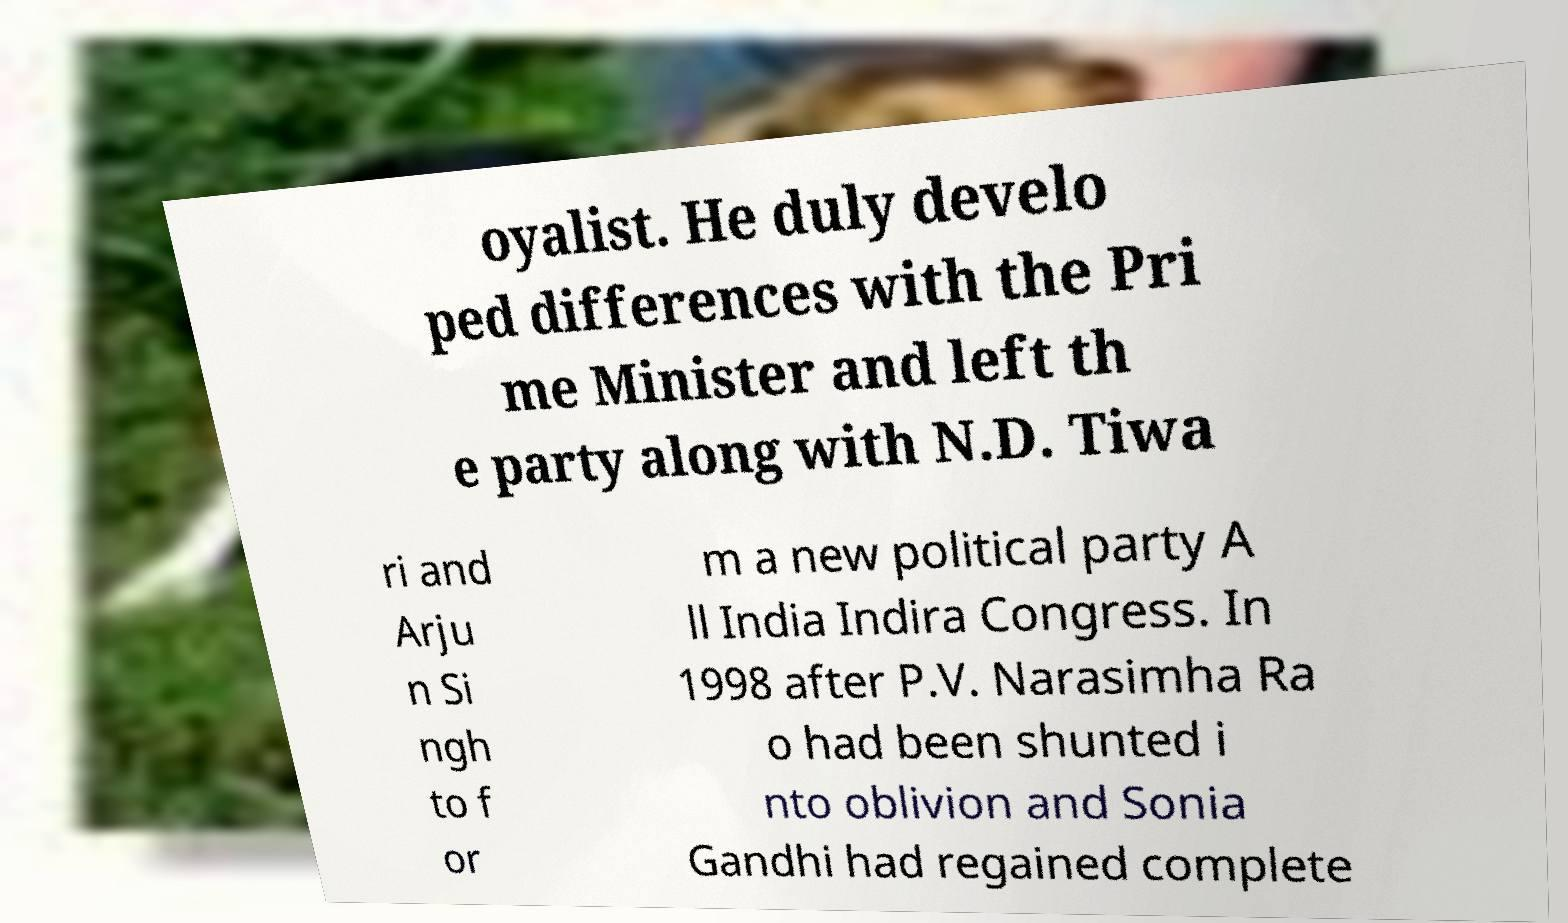Could you assist in decoding the text presented in this image and type it out clearly? oyalist. He duly develo ped differences with the Pri me Minister and left th e party along with N.D. Tiwa ri and Arju n Si ngh to f or m a new political party A ll India Indira Congress. In 1998 after P.V. Narasimha Ra o had been shunted i nto oblivion and Sonia Gandhi had regained complete 